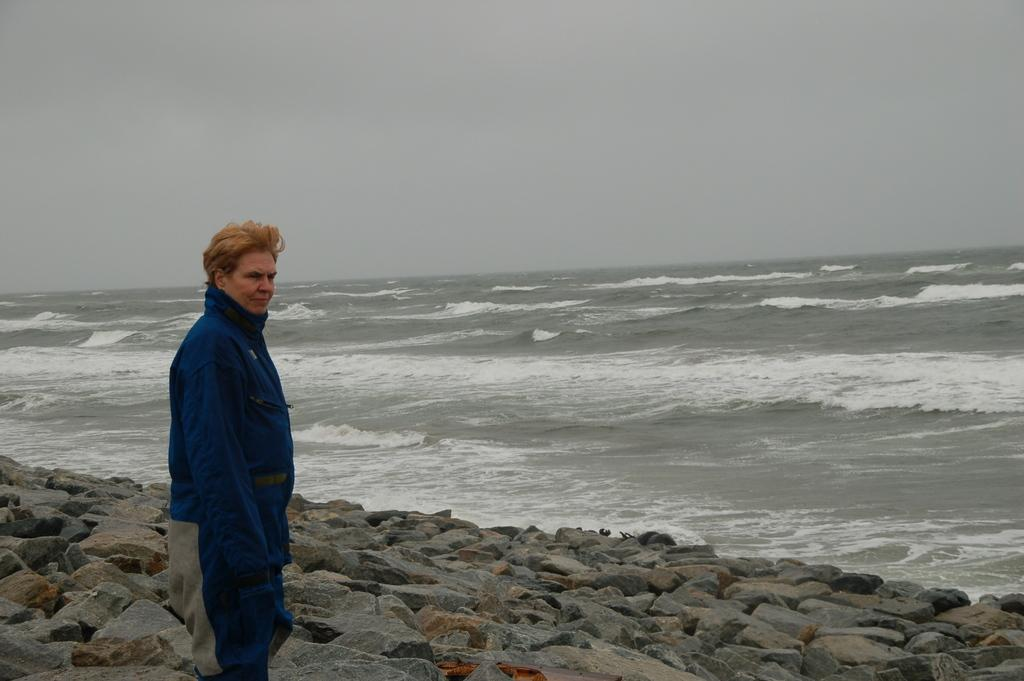What is the person in the image doing? The person is standing on stones in the image. What natural feature can be seen in the image? The sea is visible in the image. What is visible in the background of the image? The sky is visible in the background of the image. What type of umbrella is the doctor holding in the image? There is no doctor or umbrella present in the image. How does the sponge help the person standing on stones in the image? There is no sponge present in the image, so it cannot help the person standing on stones. 